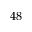<formula> <loc_0><loc_0><loc_500><loc_500>4 8</formula> 